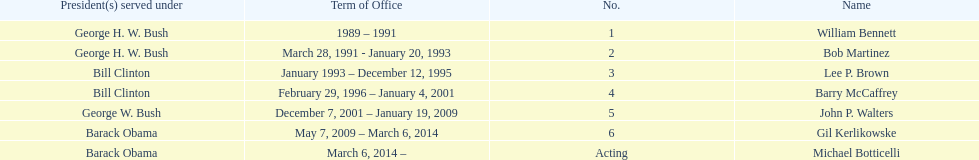What were the total number of years bob martinez served in office? 2. 